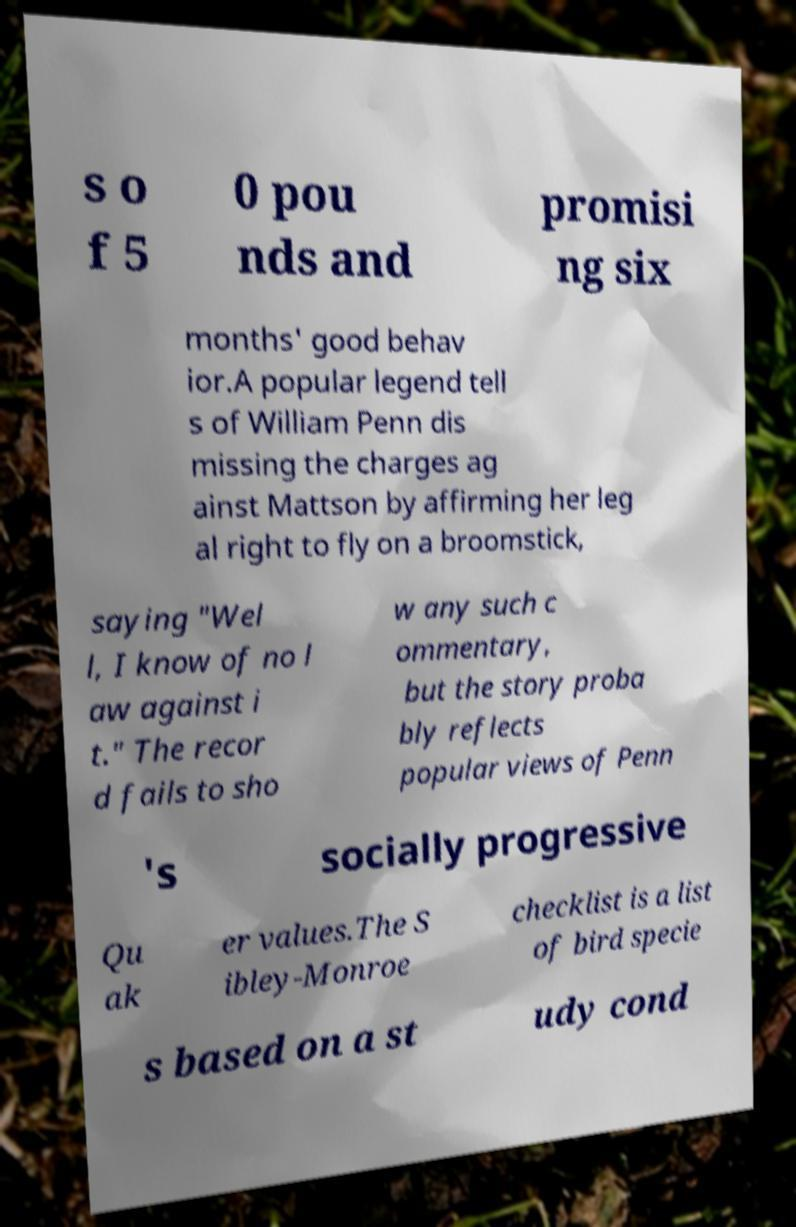Can you accurately transcribe the text from the provided image for me? s o f 5 0 pou nds and promisi ng six months' good behav ior.A popular legend tell s of William Penn dis missing the charges ag ainst Mattson by affirming her leg al right to fly on a broomstick, saying "Wel l, I know of no l aw against i t." The recor d fails to sho w any such c ommentary, but the story proba bly reflects popular views of Penn 's socially progressive Qu ak er values.The S ibley-Monroe checklist is a list of bird specie s based on a st udy cond 